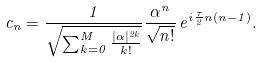<formula> <loc_0><loc_0><loc_500><loc_500>c _ { n } = \frac { 1 } { \sqrt { \sum _ { k = 0 } ^ { M } \frac { | \alpha | ^ { 2 k } } { k ! } } } \frac { \alpha ^ { n } } { \sqrt { n ! } } \, e ^ { i \frac { \tau } { 2 } n ( n - 1 ) } .</formula> 